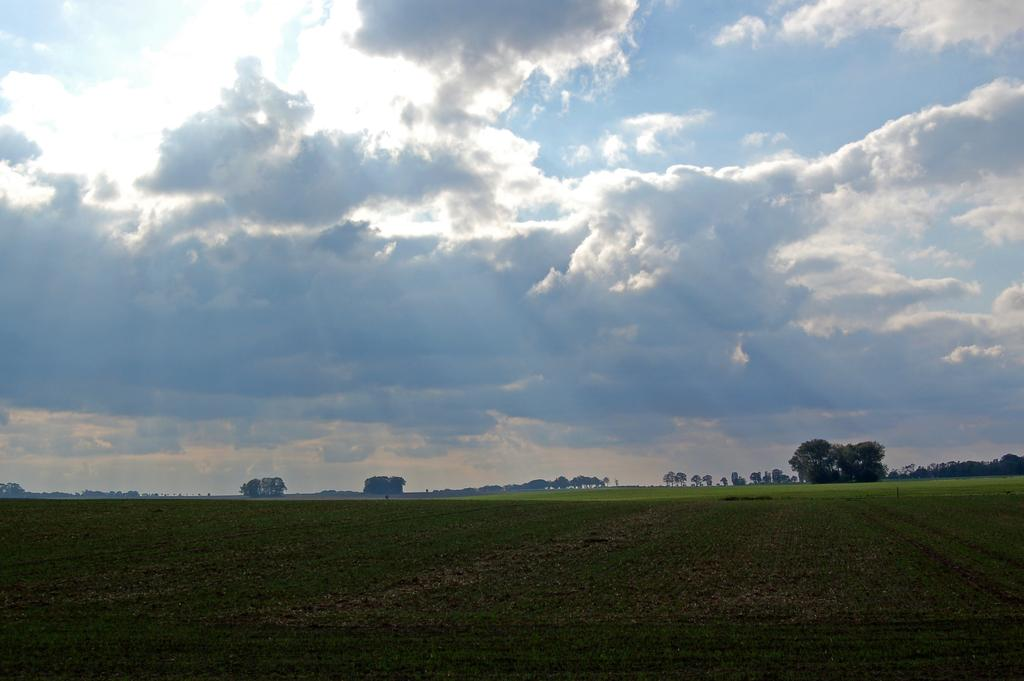What type of landscape is visible at the bottom of the image? There are fields at the bottom of the image. What can be seen in the background of the image? There are trees and clouds in the background of the image. What is visible at the top of the image? The sky is visible at the top of the image. Where is the girl sitting on the wheel in the image? There is no girl or wheel present in the image. 